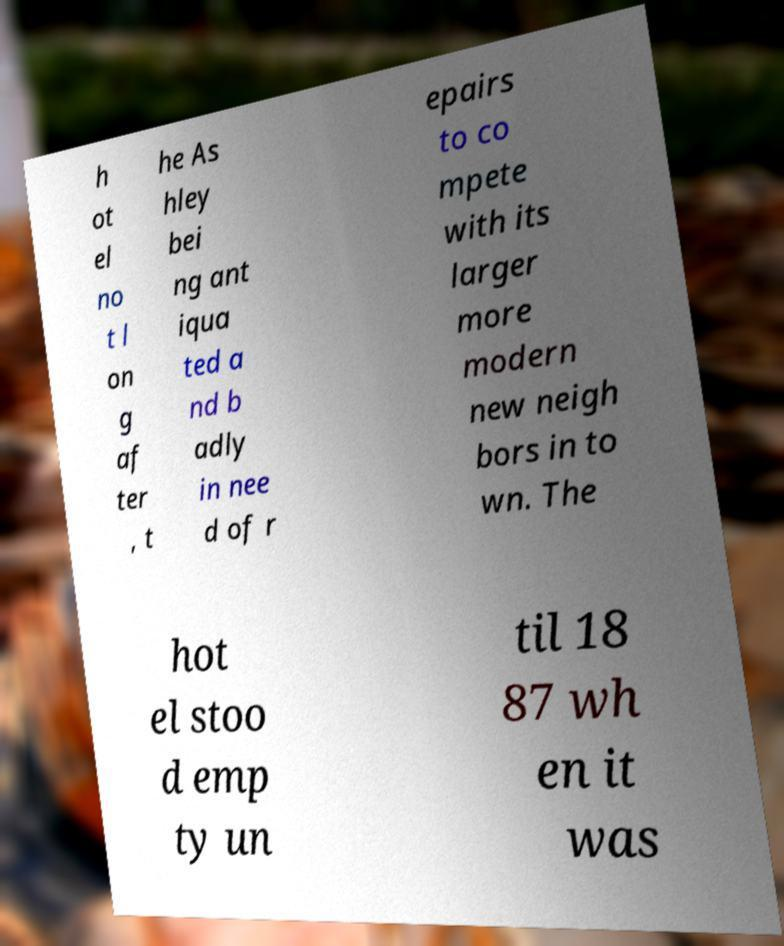Could you assist in decoding the text presented in this image and type it out clearly? h ot el no t l on g af ter , t he As hley bei ng ant iqua ted a nd b adly in nee d of r epairs to co mpete with its larger more modern new neigh bors in to wn. The hot el stoo d emp ty un til 18 87 wh en it was 